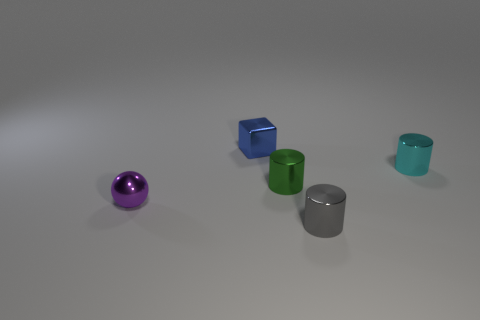Add 2 tiny blue shiny cubes. How many objects exist? 7 Subtract all cubes. How many objects are left? 4 Subtract 1 cyan cylinders. How many objects are left? 4 Subtract all cyan shiny things. Subtract all shiny spheres. How many objects are left? 3 Add 3 metallic cylinders. How many metallic cylinders are left? 6 Add 2 big purple things. How many big purple things exist? 2 